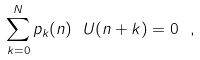Convert formula to latex. <formula><loc_0><loc_0><loc_500><loc_500>\sum _ { k = 0 } ^ { N } p _ { k } ( n ) \ U ( n + k ) = 0 \ ,</formula> 